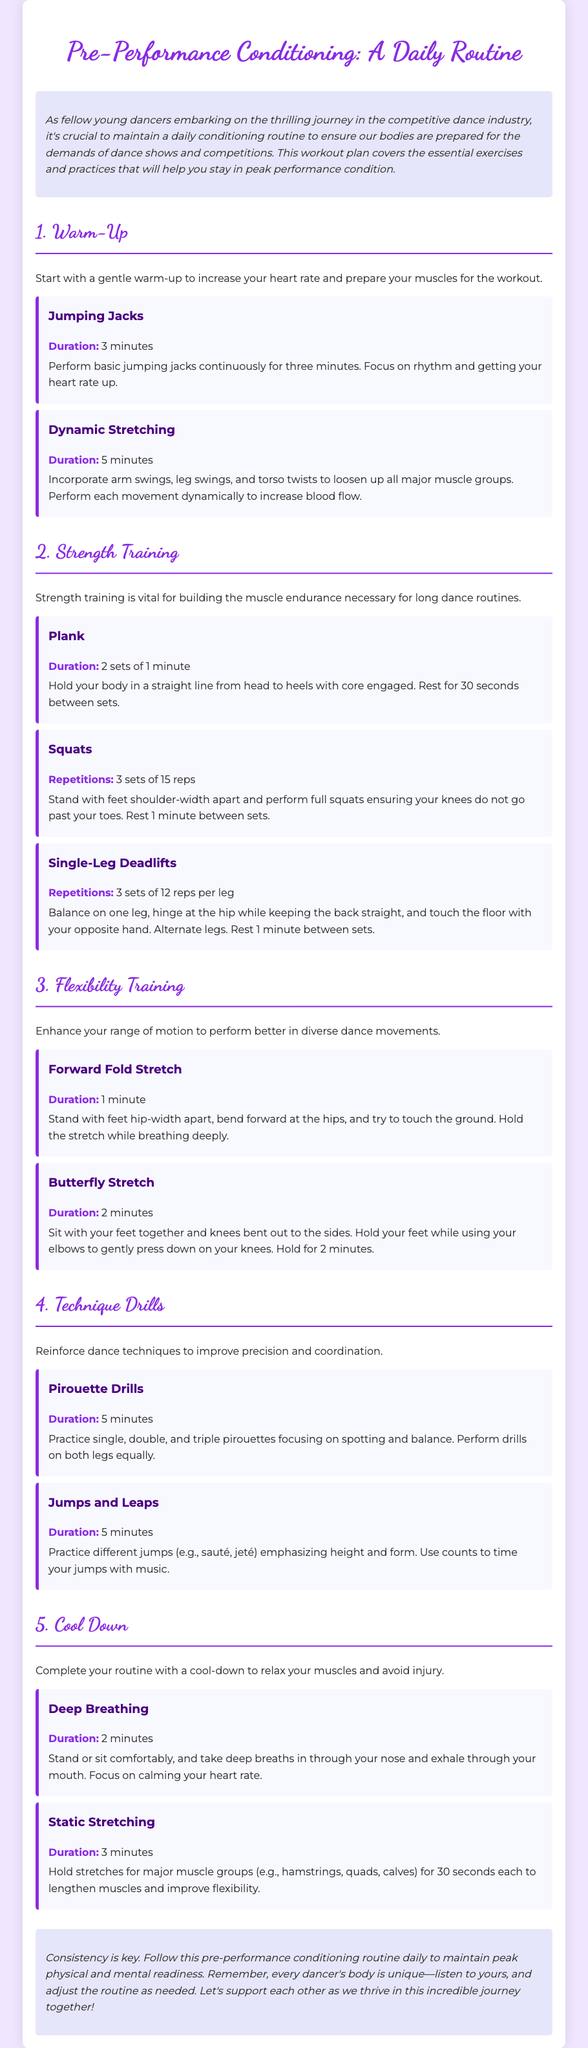What is the duration of Jumping Jacks? The duration for Jumping Jacks is specified in the exercise section as 3 minutes.
Answer: 3 minutes How many sets are recommended for Plank? The exercise section states to perform 2 sets of 1 minute for Plank.
Answer: 2 sets of 1 minute What two types of training does the document emphasize? The routine highlights Strength Training and Flexibility Training, which are main sections in the workout plan.
Answer: Strength Training and Flexibility Training What stretch should be held for 2 minutes? The document indicates that the Butterfly Stretch should be held for 2 minutes in the Flexibility Training section.
Answer: Butterfly Stretch How long should the Cool Down step take in total? The total duration for Cool Down includes 2 minutes for Deep Breathing and 3 minutes for Static Stretching, making it 5 minutes in total.
Answer: 5 minutes Which drill focuses on enhancing balance? The Pirouette Drills, mentioned in the Technique Drills section, focus on improving spotting and balance.
Answer: Pirouette Drills What is the purpose of the Warm-Up section? The Warm-Up section aims to increase heart rate and prepare muscles, serving as an introduction to the workout routine.
Answer: Increase heart rate and prepare muscles What is the main goal of the entire document? The overall aim of the document is to provide a daily conditioning routine to prepare dancers for shows and competitions, as stated in the introduction.
Answer: Prepare dancers for shows and competitions 